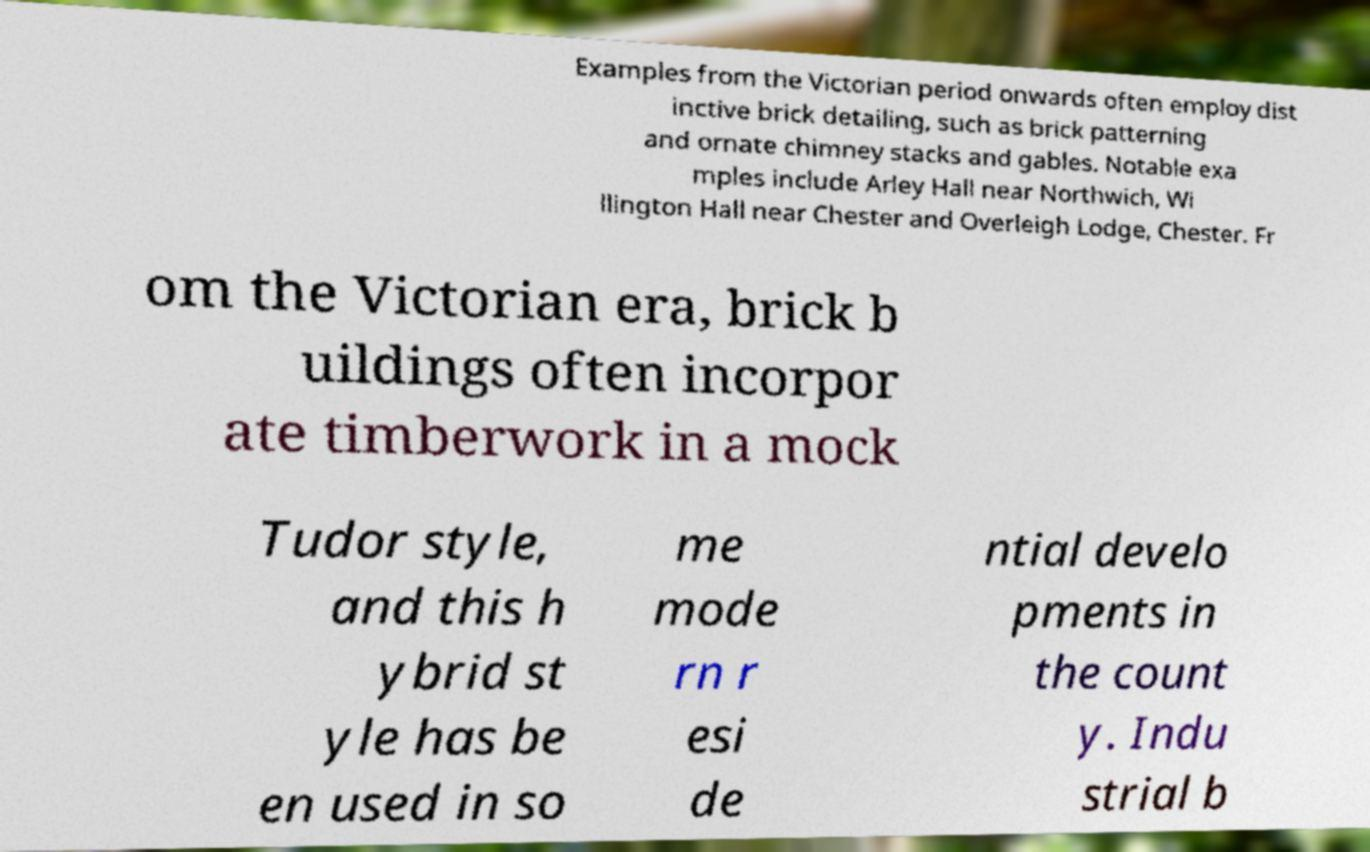Please identify and transcribe the text found in this image. Examples from the Victorian period onwards often employ dist inctive brick detailing, such as brick patterning and ornate chimney stacks and gables. Notable exa mples include Arley Hall near Northwich, Wi llington Hall near Chester and Overleigh Lodge, Chester. Fr om the Victorian era, brick b uildings often incorpor ate timberwork in a mock Tudor style, and this h ybrid st yle has be en used in so me mode rn r esi de ntial develo pments in the count y. Indu strial b 